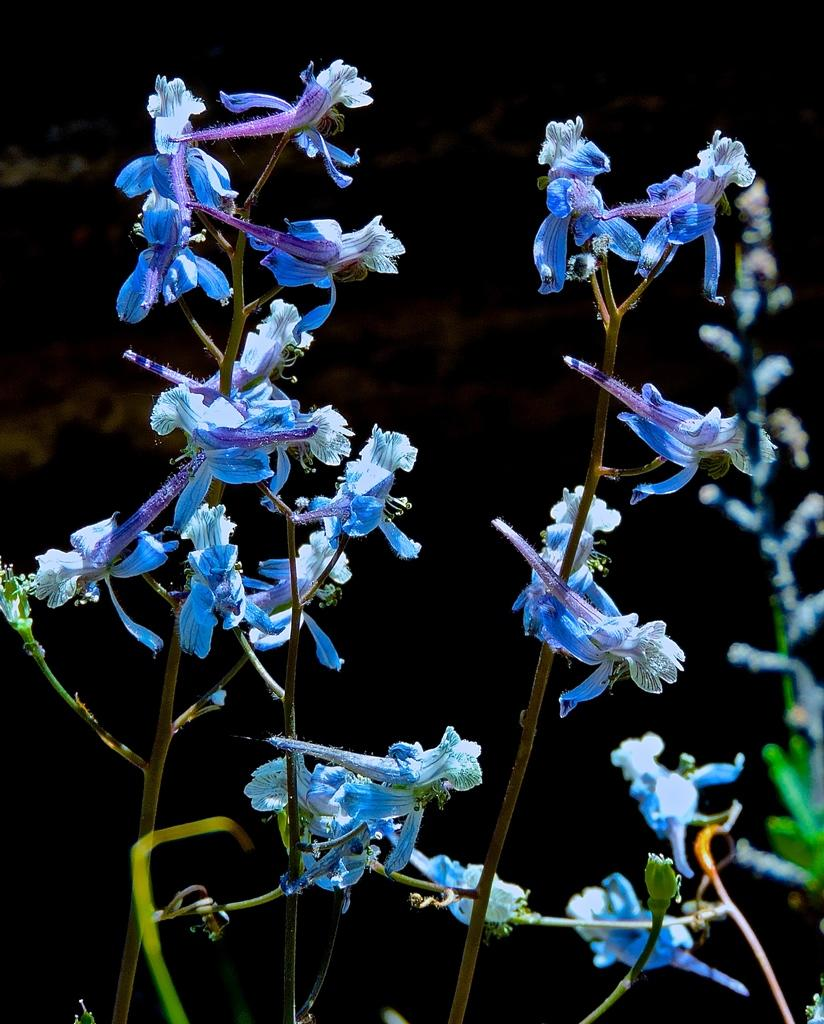What types of living organisms can be seen in the image? Plants and flowers are visible in the image. Can you describe the background of the image? The background of the image is dark. What type of wool can be seen in the image? There is no wool present in the image. How many bikes are visible in the image? There are no bikes present in the image. 